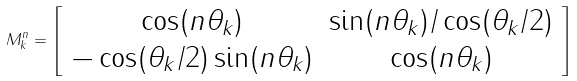<formula> <loc_0><loc_0><loc_500><loc_500>M _ { k } ^ { n } = \left [ \begin{array} { c c } \cos ( n \theta _ { k } ) & \sin ( n \theta _ { k } ) / \cos ( \theta _ { k } / 2 ) \\ - \cos ( \theta _ { k } / 2 ) \sin ( n \theta _ { k } ) & \cos ( n \theta _ { k } ) \end{array} \right ]</formula> 